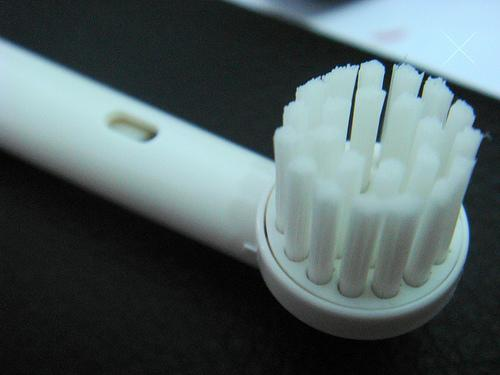Can you identify any special features or patterns on the toothbrush? The bristles on the toothbrush are arranged in circular patterns and there are small holes in the toothbrush. State the main purpose of the object seen in the image. The main purpose of the toothbrush is for brushing teeth. How would you describe the cleanliness of the object? The toothbrush appears to be clean. What openings can be seen on the object? There are small holes in the white toothbrush, along with an opening near its top. Describe the arrangement of the bristles on the object. The bristles on the toothbrush are arranged in circular patterns and each hole has multiple bristles in it. What can you infer about the background in the image? There is something white in the background of the image. What could be one possible additional feature the object might have? The toothbrush probably vibrates for thorough cleaning. Describe the surface on which the toothbrush is placed. The toothbrush is placed on a black table. What is the main object in the image and what color is it? The main object is a white toothbrush with bristles. Describe the two main sections of the object. The two main sections of the toothbrush are the handle and the bristle head. 